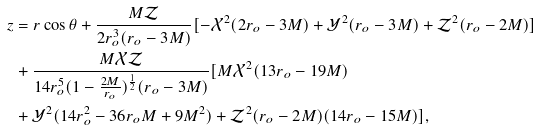Convert formula to latex. <formula><loc_0><loc_0><loc_500><loc_500>z & = r \cos \theta + \frac { M \mathcal { Z } } { 2 r _ { o } ^ { 3 } ( r _ { o } - 3 M ) } [ - \mathcal { X } ^ { 2 } ( 2 r _ { o } - 3 M ) + \mathcal { Y } ^ { 2 } ( r _ { o } - 3 M ) + \mathcal { Z } ^ { 2 } ( r _ { o } - 2 M ) ] \\ & + \frac { M \mathcal { X Z } } { 1 4 r _ { o } ^ { 5 } ( 1 - \frac { 2 M } { r _ { o } } ) ^ { \frac { 1 } { 2 } } ( r _ { o } - 3 M ) } [ M \mathcal { X } ^ { 2 } ( 1 3 r _ { o } - 1 9 M ) \\ & + \mathcal { Y } ^ { 2 } ( 1 4 r _ { o } ^ { 2 } - 3 6 r _ { o } M + 9 M ^ { 2 } ) + \mathcal { Z } ^ { 2 } ( r _ { o } - 2 M ) ( 1 4 r _ { o } - 1 5 M ) ] , \\</formula> 